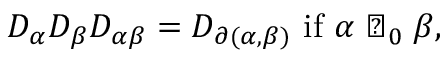<formula> <loc_0><loc_0><loc_500><loc_500>D _ { \alpha } D _ { \beta } D _ { \alpha \beta } = D _ { \partial ( \alpha , \beta ) } i f \alpha \perp _ { 0 } \beta ,</formula> 